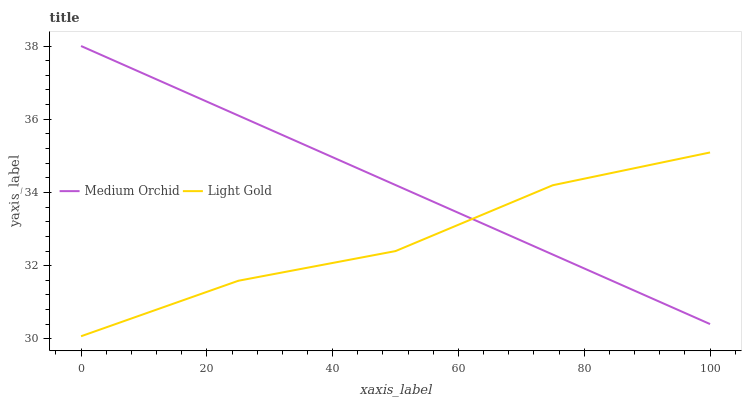Does Light Gold have the minimum area under the curve?
Answer yes or no. Yes. Does Medium Orchid have the maximum area under the curve?
Answer yes or no. Yes. Does Light Gold have the maximum area under the curve?
Answer yes or no. No. Is Medium Orchid the smoothest?
Answer yes or no. Yes. Is Light Gold the roughest?
Answer yes or no. Yes. Is Light Gold the smoothest?
Answer yes or no. No. Does Light Gold have the lowest value?
Answer yes or no. Yes. Does Medium Orchid have the highest value?
Answer yes or no. Yes. Does Light Gold have the highest value?
Answer yes or no. No. Does Medium Orchid intersect Light Gold?
Answer yes or no. Yes. Is Medium Orchid less than Light Gold?
Answer yes or no. No. Is Medium Orchid greater than Light Gold?
Answer yes or no. No. 